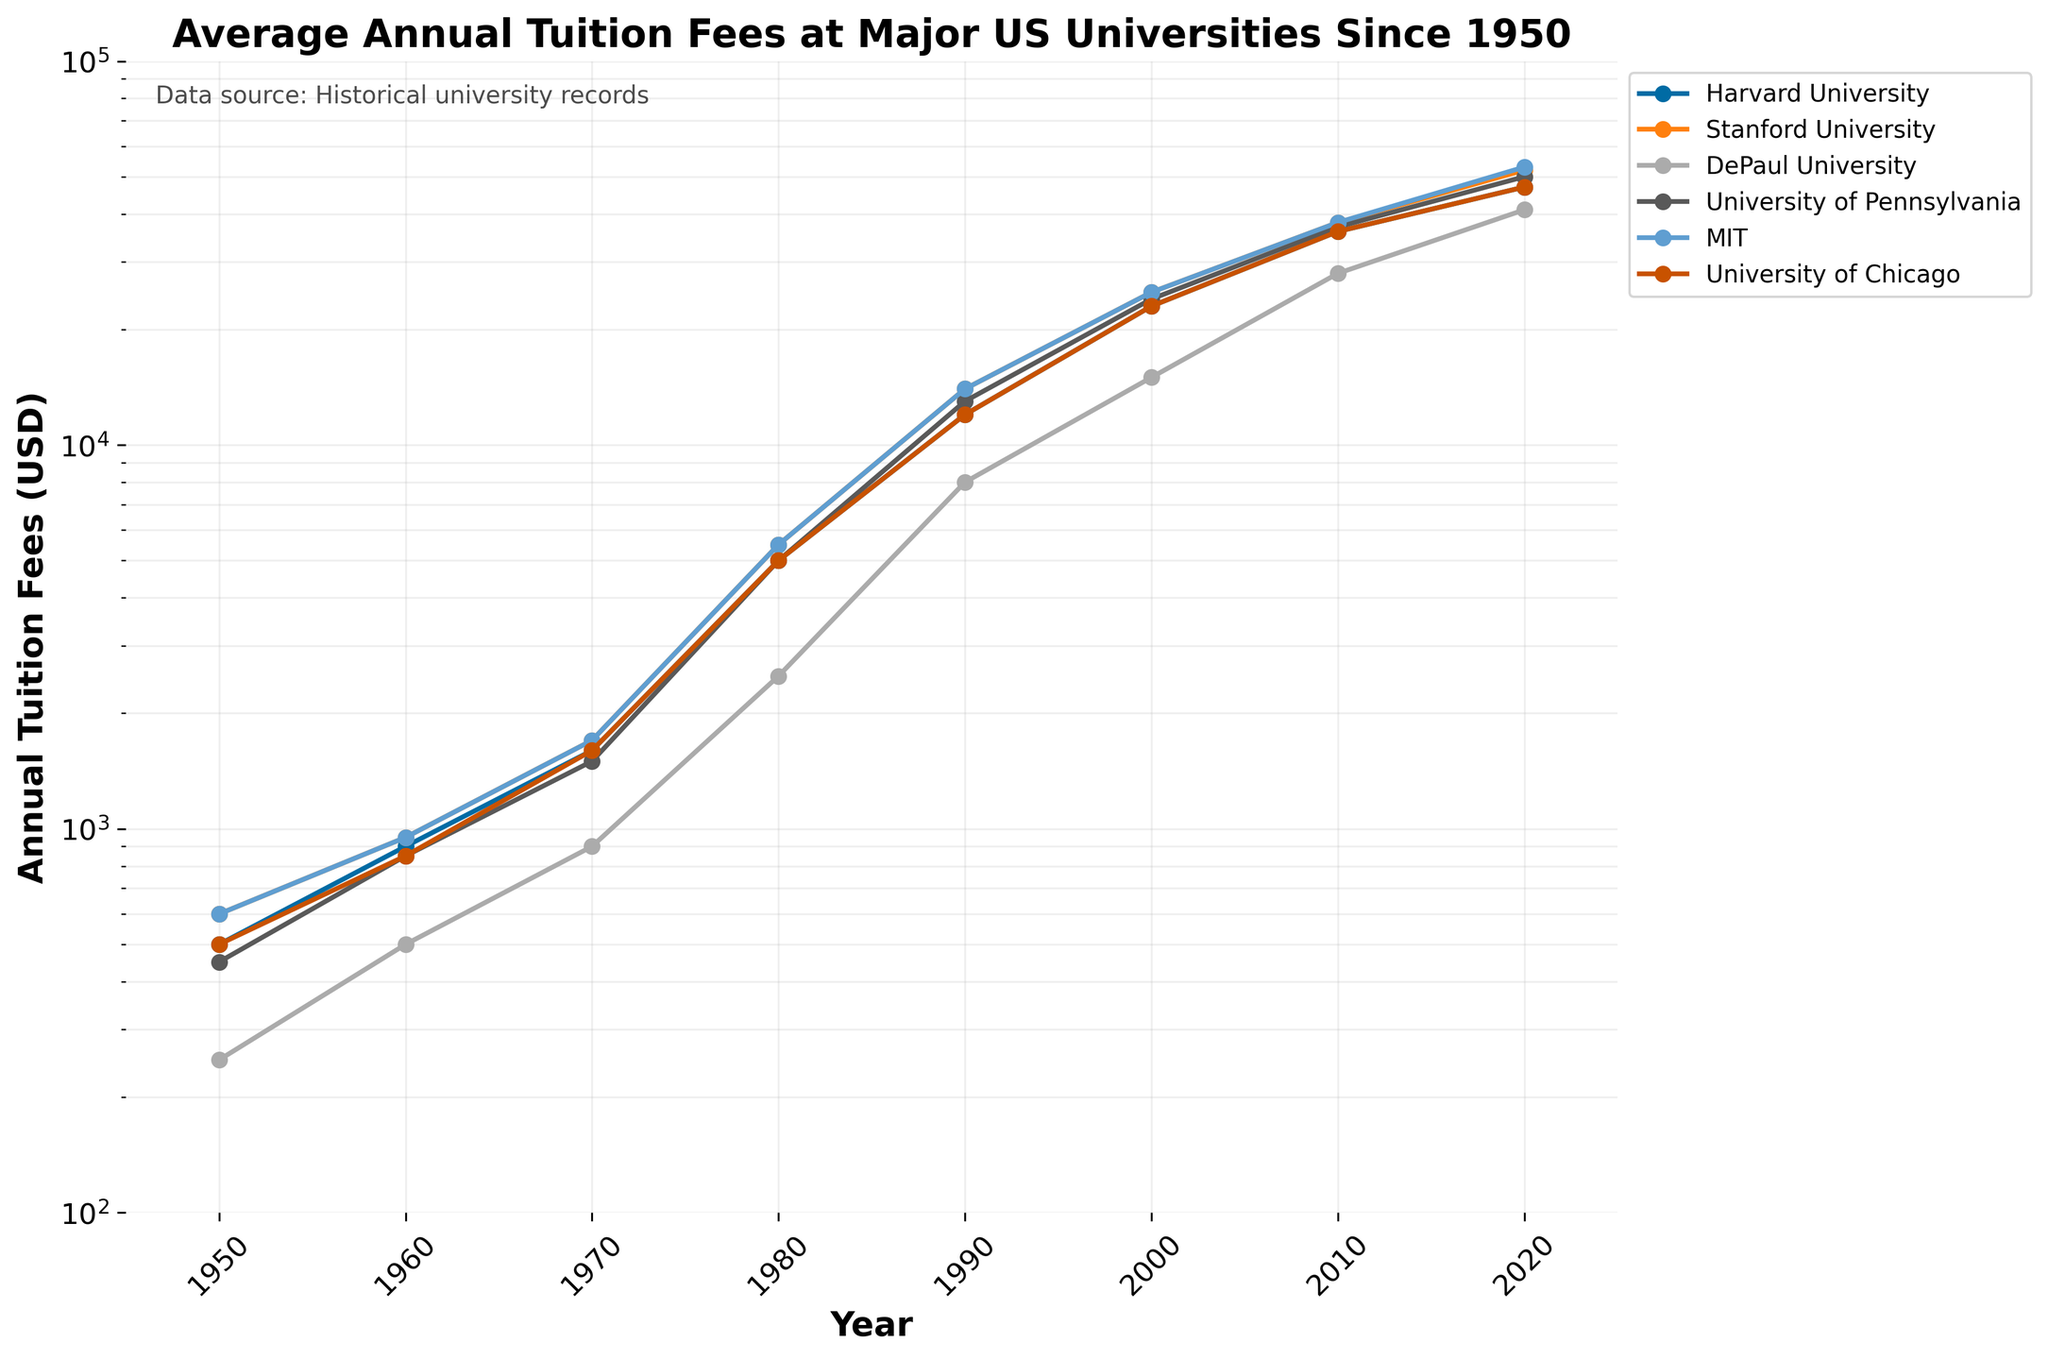Which university had the highest tuition fees in 2020? Look at the y-axis value for the year 2020 and identify which university's line reaches the highest point. MIT's line is the highest in 2020.
Answer: MIT What is the overall trend in tuition fees for DePaul University from 1950 to 2020? Identify the positions of DePaul University's line across different years. The line consistently trends upward from 1950 to 2020.
Answer: Upward Which university's tuition fees increased the most between 1950 and 2020? Compare the distances between the y-axis values for each university from 1950 to 2020. MIT's fees went from 600 in 1950 to 53000 in 2020, the most significant increase.
Answer: MIT By how much did the tuition fees for the University of Chicago increase between 1980 and 1990? Locate the data points for the University of Chicago for 1980 and 1990 and calculate the difference. The fees increased from 5000 in 1980 to 12000 in 1990.
Answer: 7000 What's the average tuition fee for Harvard University from 1950 to 2020? Add the tuition fees for Harvard University for each available year and divide by the number of data points. (500 + 900 + 1600 + 5000 + 12000 + 23000 + 36000 + 47000) / 8 = 15750.
Answer: 15750 Which university had higher tuition fees in 1960, Stanford University or University of Pennsylvania? Compare the y-axis values for Stanford University and the University of Pennsylvania in 1960. Both have tuition fees at 950 and 850, respectively.
Answer: Stanford University What is the compound annual growth rate (CAGR) of MIT's tuition fees from 1950 to 2020? Use the formula for CAGR: (Ending Value / Beginning Value)^(1/n) - 1, where n is the number of years. For MIT, it is (53000/600)^(1/70) - 1. Solve this calculation.
Answer: ~0.0736 or 7.36% How does the tuition growth rate of DePaul University from 2000 to 2010 compare to its growth rate from 2010 to 2020? Calculate the growth rate for each period: (2010 tuition/2000 tuition - 1) and (2020 tuition/2010 tuition - 1), then compare the two. For DePaul: (28000/15000 - 1) and (41000/28000 - 1). Growth rates are ~0.87 and ~0.464.
Answer: Faster 2000-2010 In which decade did Stanford University see the highest relative increase in tuition fees? Calculate the percentage increase for each decade and compare. For Stanford: [(950-600)/600, (1700-950)/950, (5500-1700)/1700, (14000-5500)/5500, (25000-14000)/14000, (38000-25000)/25000, (52000-38000)/38000]. 1970-1980 has 223.5%.
Answer: 1970-1980 